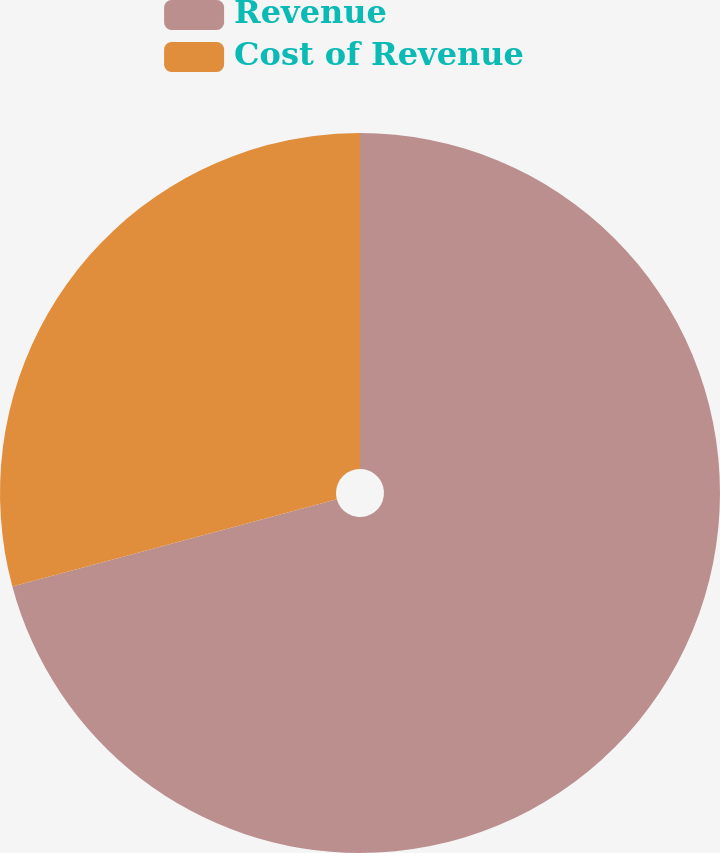Convert chart. <chart><loc_0><loc_0><loc_500><loc_500><pie_chart><fcel>Revenue<fcel>Cost of Revenue<nl><fcel>70.82%<fcel>29.18%<nl></chart> 